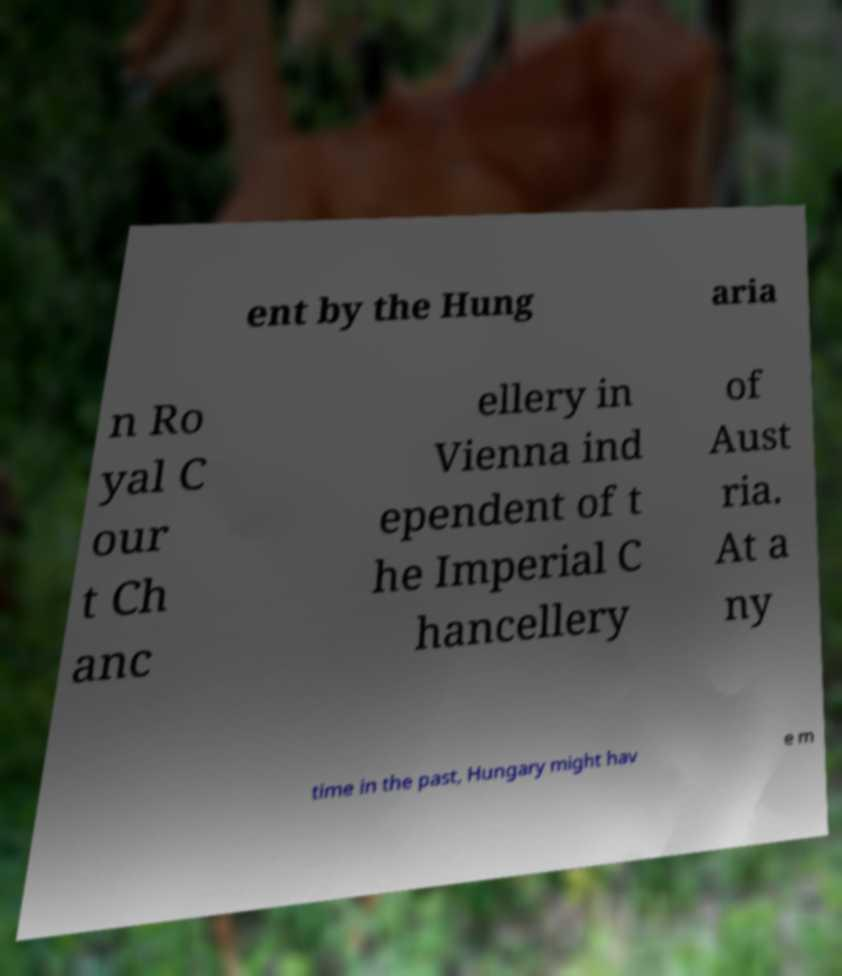Can you accurately transcribe the text from the provided image for me? ent by the Hung aria n Ro yal C our t Ch anc ellery in Vienna ind ependent of t he Imperial C hancellery of Aust ria. At a ny time in the past, Hungary might hav e m 